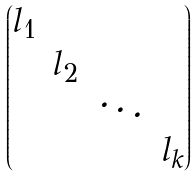Convert formula to latex. <formula><loc_0><loc_0><loc_500><loc_500>\begin{pmatrix} l _ { 1 } \\ & l _ { 2 } \\ & & \ddots \\ & & & l _ { k } \end{pmatrix}</formula> 